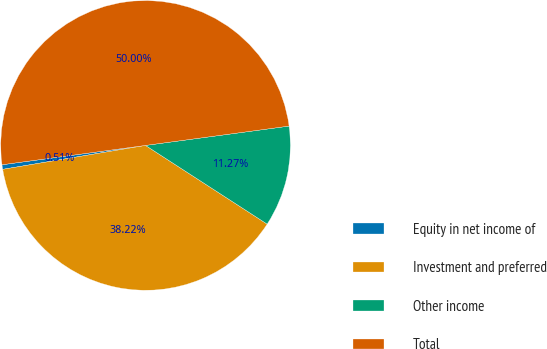Convert chart. <chart><loc_0><loc_0><loc_500><loc_500><pie_chart><fcel>Equity in net income of<fcel>Investment and preferred<fcel>Other income<fcel>Total<nl><fcel>0.51%<fcel>38.22%<fcel>11.27%<fcel>50.0%<nl></chart> 